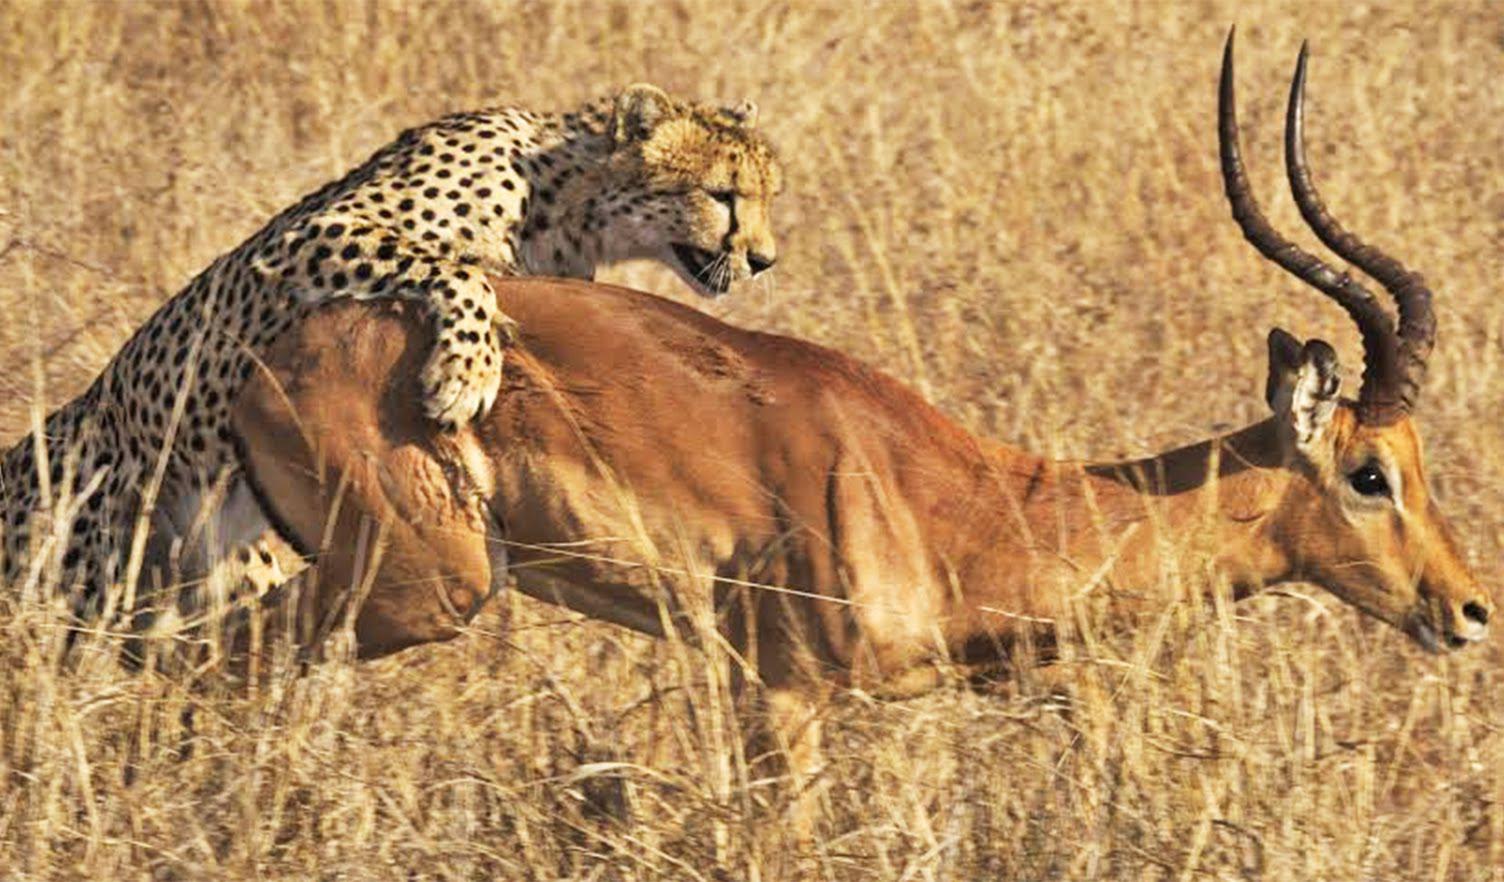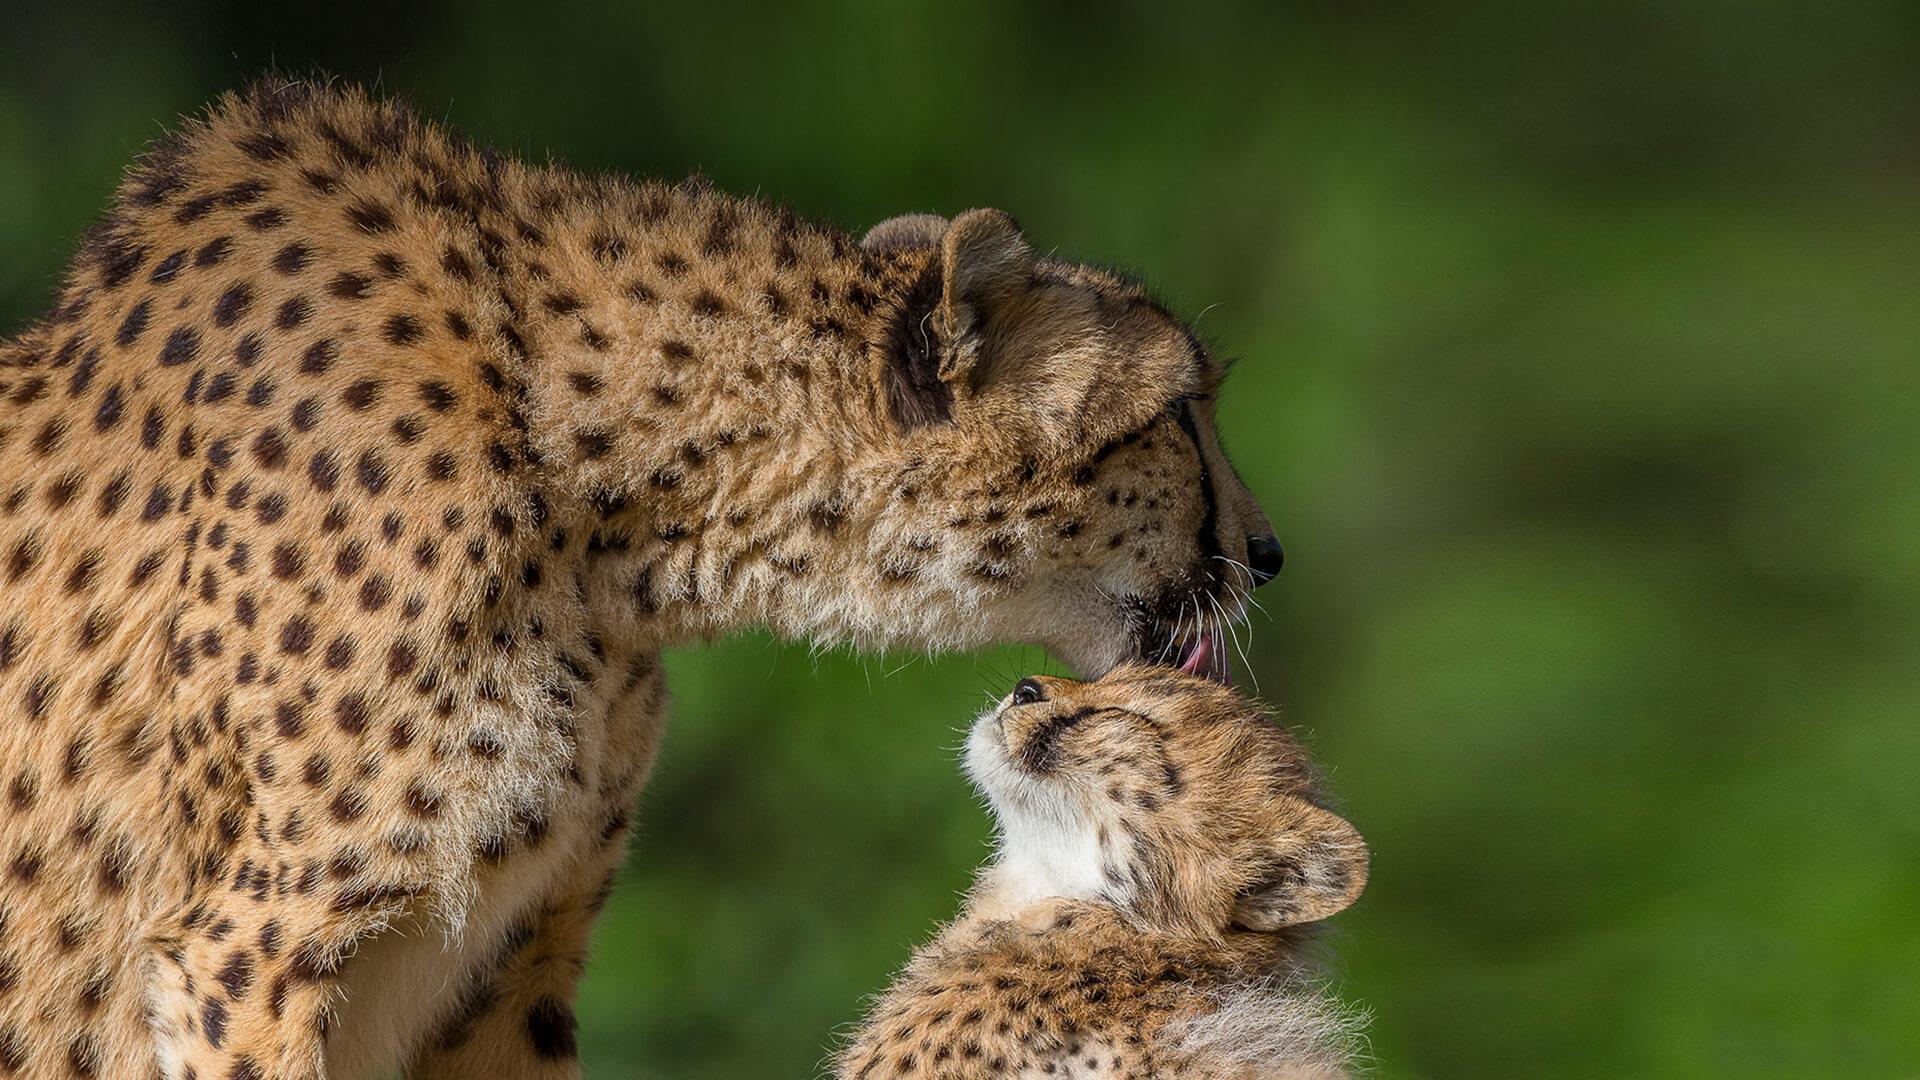The first image is the image on the left, the second image is the image on the right. Assess this claim about the two images: "A cheetah is grabbing its prey from behind in the left image.". Correct or not? Answer yes or no. Yes. The first image is the image on the left, the second image is the image on the right. Examine the images to the left and right. Is the description "An image shows a spotted wild cat jumping a horned animal from behind." accurate? Answer yes or no. Yes. 